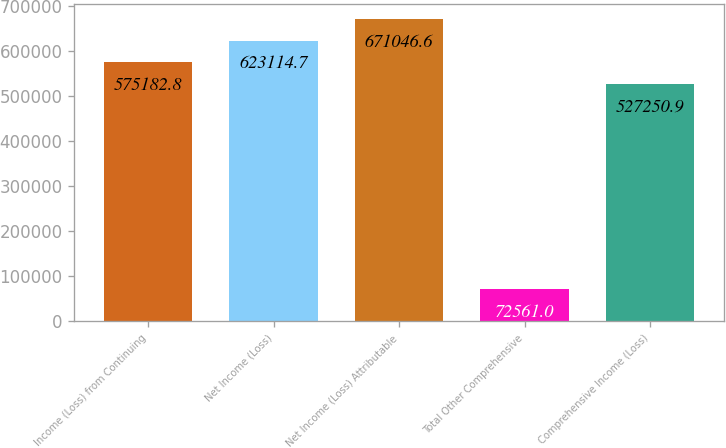<chart> <loc_0><loc_0><loc_500><loc_500><bar_chart><fcel>Income (Loss) from Continuing<fcel>Net Income (Loss)<fcel>Net Income (Loss) Attributable<fcel>Total Other Comprehensive<fcel>Comprehensive Income (Loss)<nl><fcel>575183<fcel>623115<fcel>671047<fcel>72561<fcel>527251<nl></chart> 